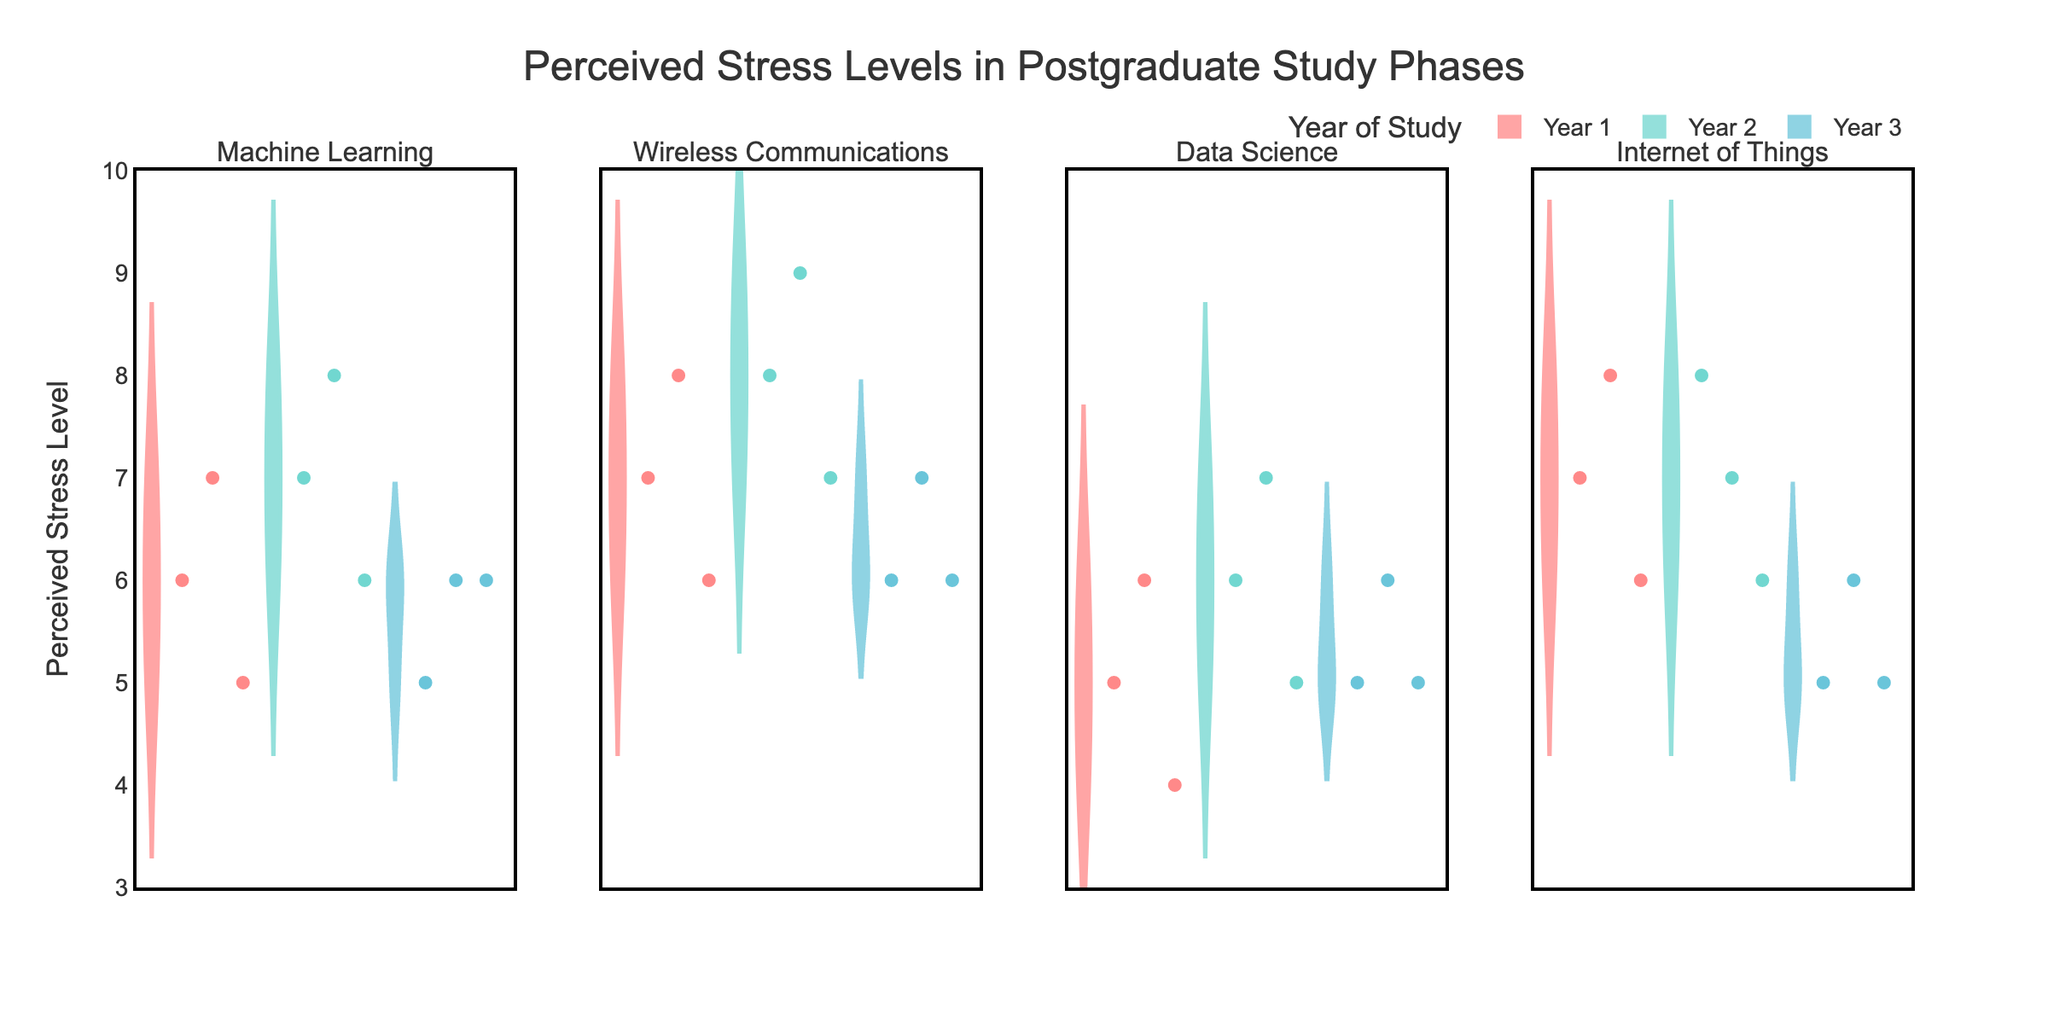What is the title of the figure? The title of the figure is displayed at the top of the plot. It reads "Perceived Stress Levels in Postgraduate Study Phases."
Answer: Perceived Stress Levels in Postgraduate Study Phases Which research area shows the highest perceived stress level in the 2nd year of study? To determine this, look at the violin plots for each research area for the 2nd year. The peak perceived stress level is observed in "Wireless Communications," showing a maximum of 9.
Answer: Wireless Communications In the first year of study, which research area shows the lowest perceived stress levels? Observe the minimum values within the first year plots. "Data Science" shows the lowest perceived stress levels, visible at a minimum of 4.
Answer: Data Science What is the perceived stress level range for the Internet of Things research area in the 3rd year? The range is found by looking at the lowest and highest points within the 3rd-year violin plot for Internet of Things. The range is from 5 to 6.
Answer: 5 to 6 How does the median perceived stress level of 1st-year students in Machine Learning compare to the median perceived stress level of 3rd-year students in the same area? Compare the median lines within the 1st and 3rd-year plots for Machine Learning. The median for the 1st year is around 6, while for the 3rd year it is also around 6. They are the same.
Answer: The same What general trend is visible in the perceived stress levels in Data Science across the study years? Observe the density and positioning of the violin plots across the years in Data Science. The perceived stress levels appear to remain relatively stable, varying between approximately 4 to 7 across all years.
Answer: Relatively stable In the 2nd year, which research area has the highest median perceived stress level? Look at the plot's median lines for each research area in the 2nd year. "Wireless Communications" shows the highest median at 8.
Answer: Wireless Communications For Machine Learning students, how does the distribution of perceived stress levels change from the 1st to the 3rd year? Compare the shapes and spreads of the violin plots for Machine Learning across the years. The 1st year has a wider spread, the 2nd year shifts slightly higher, and the 3rd-year distribution narrows around the median, showing reduced spread.
Answer: Narrowed around median What pattern do you observe in the perceived stress levels for Wireless Communications students across the study years? Look at the violin plots for each year in Wireless Communications. There's a consistent increase in stress levels from the 1st to 2nd year, followed by a slight decrease in the 3rd year.
Answer: Increase then slight decrease Which year of study generally shows the highest perceived stress levels across all research areas? Identify the densest and highest points in the violins' plots across all areas for each year. The 2nd year generally shows higher perceived stress levels than the 1st and 3rd years.
Answer: 2nd year 